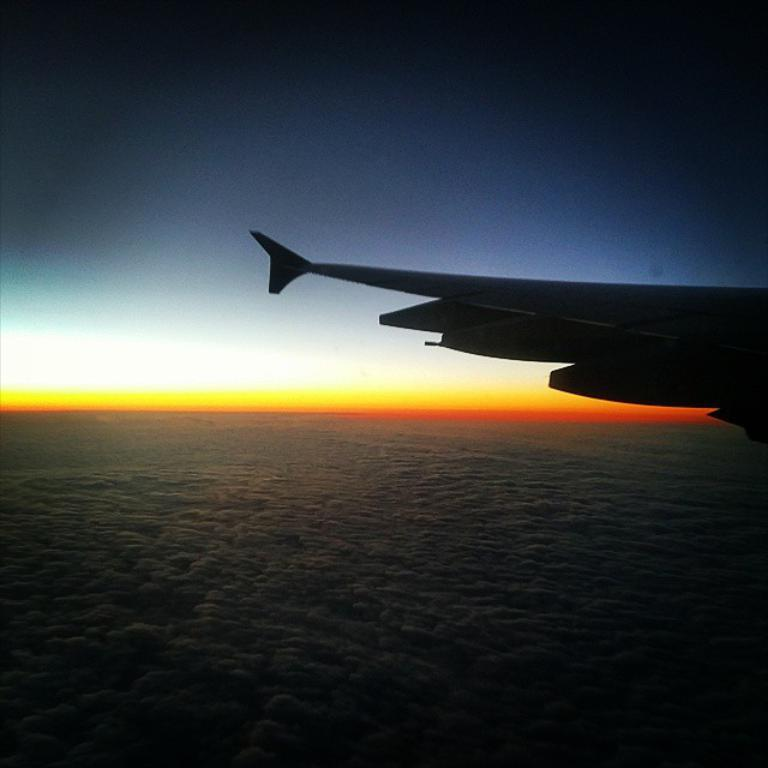What is located at the bottom of the image? There is a water body at the bottom of the image. What can be seen on the right side of the image? There is an airplane wing on the right side of the image. What is visible at the top of the image? The sky is visible at the top of the image. Where is the sofa located in the image? There is no sofa present in the image. What type of control is used to operate the airplane wing in the image? The image does not show any controls for operating the airplane wing, as it is a static image. 